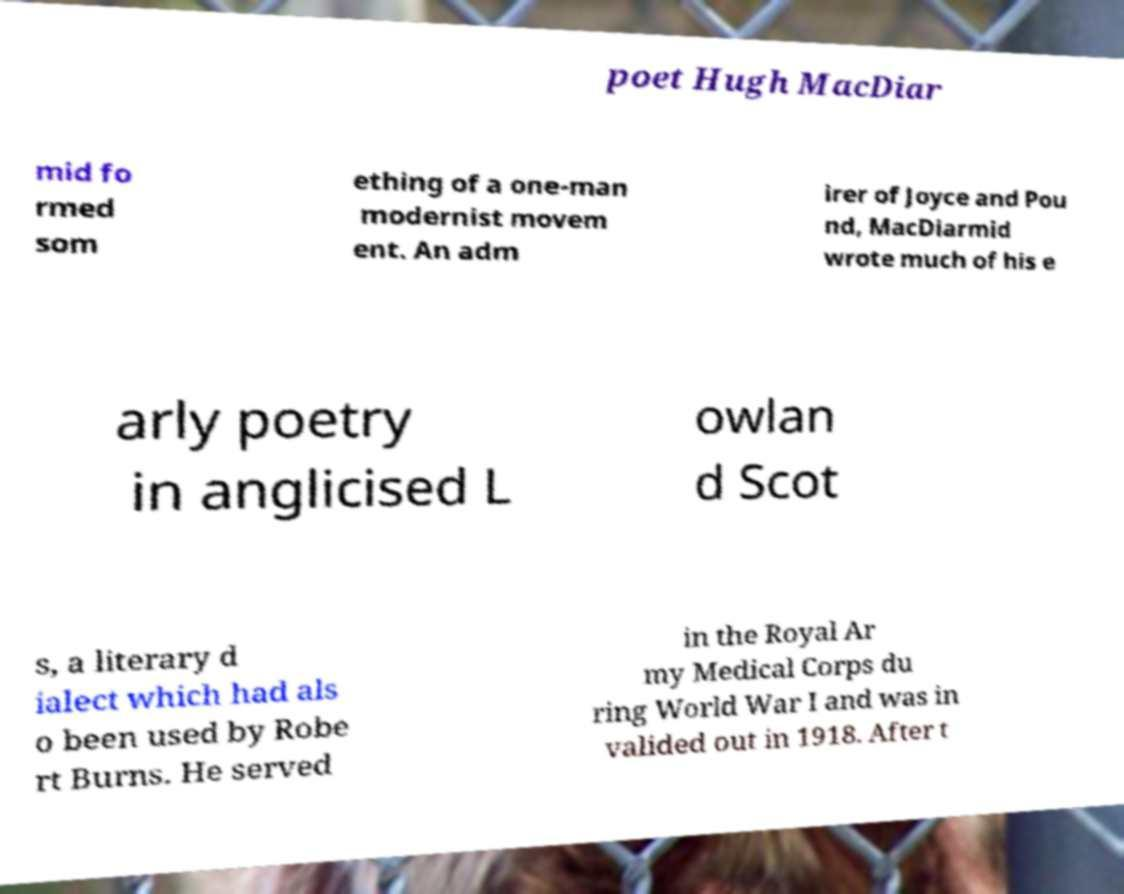Please read and relay the text visible in this image. What does it say? poet Hugh MacDiar mid fo rmed som ething of a one-man modernist movem ent. An adm irer of Joyce and Pou nd, MacDiarmid wrote much of his e arly poetry in anglicised L owlan d Scot s, a literary d ialect which had als o been used by Robe rt Burns. He served in the Royal Ar my Medical Corps du ring World War I and was in valided out in 1918. After t 